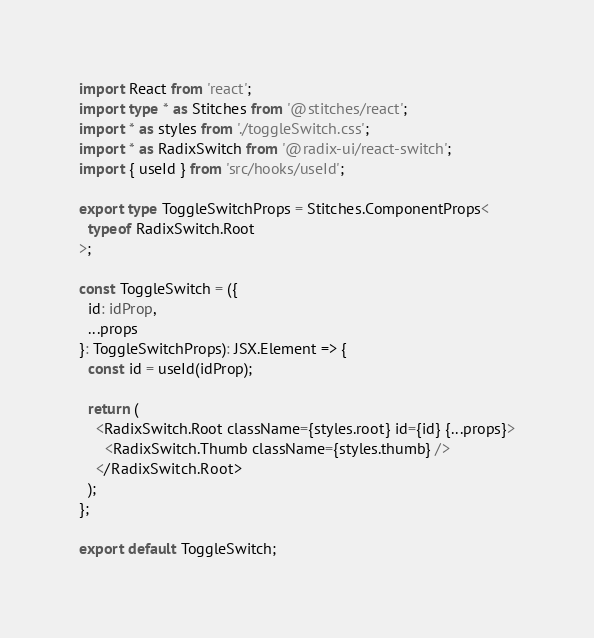Convert code to text. <code><loc_0><loc_0><loc_500><loc_500><_TypeScript_>import React from 'react';
import type * as Stitches from '@stitches/react';
import * as styles from './toggleSwitch.css';
import * as RadixSwitch from '@radix-ui/react-switch';
import { useId } from 'src/hooks/useId';

export type ToggleSwitchProps = Stitches.ComponentProps<
  typeof RadixSwitch.Root
>;

const ToggleSwitch = ({
  id: idProp,
  ...props
}: ToggleSwitchProps): JSX.Element => {
  const id = useId(idProp);

  return (
    <RadixSwitch.Root className={styles.root} id={id} {...props}>
      <RadixSwitch.Thumb className={styles.thumb} />
    </RadixSwitch.Root>
  );
};

export default ToggleSwitch;
</code> 